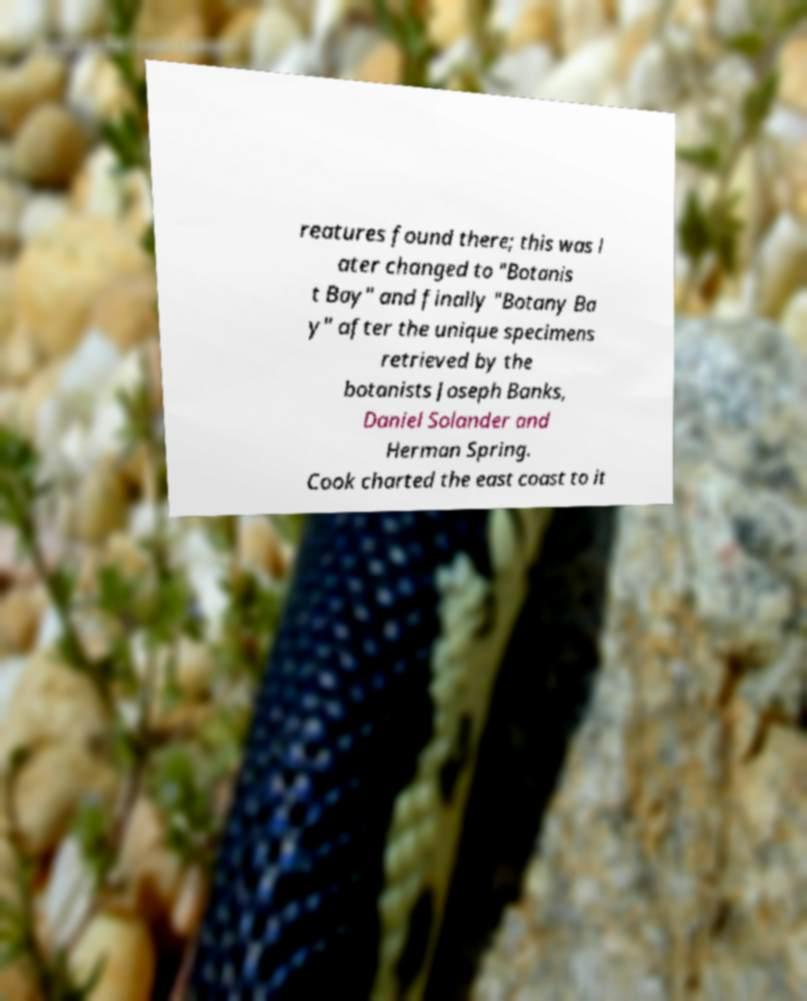Please identify and transcribe the text found in this image. reatures found there; this was l ater changed to "Botanis t Bay" and finally "Botany Ba y" after the unique specimens retrieved by the botanists Joseph Banks, Daniel Solander and Herman Spring. Cook charted the east coast to it 